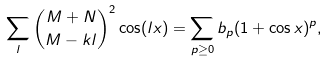Convert formula to latex. <formula><loc_0><loc_0><loc_500><loc_500>\sum _ { l } { M + N \choose M - k l } ^ { 2 } \cos ( l x ) = \sum _ { p \geq 0 } b _ { p } ( 1 + \cos x ) ^ { p } ,</formula> 